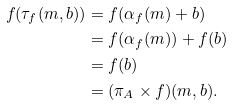Convert formula to latex. <formula><loc_0><loc_0><loc_500><loc_500>f ( \tau _ { f } ( m , b ) ) & = f ( \alpha _ { f } ( m ) + b ) \\ & = f ( \alpha _ { f } ( m ) ) + f ( b ) \\ & = f ( b ) \\ & = ( \pi _ { A } \times f ) ( m , b ) . \\</formula> 